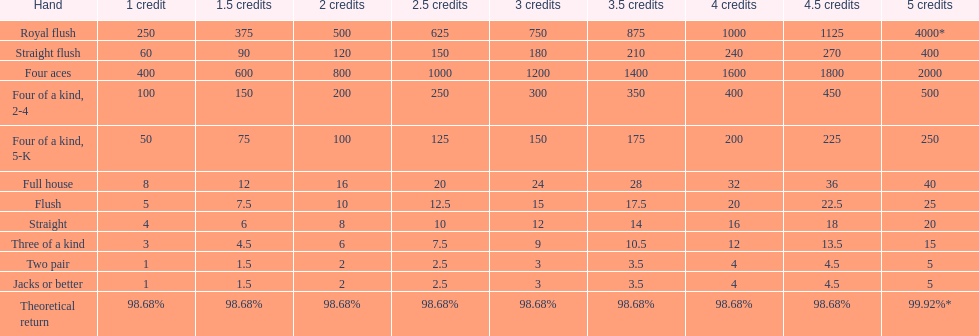Parse the full table. {'header': ['Hand', '1 credit', '1.5 credits', '2 credits', '2.5 credits', '3 credits', '3.5 credits', '4 credits', '4.5 credits', '5 credits'], 'rows': [['Royal flush', '250', '375', '500', '625', '750', '875', '1000', '1125', '4000*'], ['Straight flush', '60', '90', '120', '150', '180', '210', '240', '270', '400'], ['Four aces', '400', '600', '800', '1000', '1200', '1400', '1600', '1800', '2000'], ['Four of a kind, 2-4', '100', '150', '200', '250', '300', '350', '400', '450', '500'], ['Four of a kind, 5-K', '50', '75', '100', '125', '150', '175', '200', '225', '250'], ['Full house', '8', '12', '16', '20', '24', '28', '32', '36', '40'], ['Flush', '5', '7.5', '10', '12.5', '15', '17.5', '20', '22.5', '25'], ['Straight', '4', '6', '8', '10', '12', '14', '16', '18', '20'], ['Three of a kind', '3', '4.5', '6', '7.5', '9', '10.5', '12', '13.5', '15'], ['Two pair', '1', '1.5', '2', '2.5', '3', '3.5', '4', '4.5', '5'], ['Jacks or better', '1', '1.5', '2', '2.5', '3', '3.5', '4', '4.5', '5'], ['Theoretical return', '98.68%', '98.68%', '98.68%', '98.68%', '98.68%', '98.68%', '98.68%', '98.68%', '99.92%*']]} Is a 2 credit full house the same as a 5 credit three of a kind? No. 